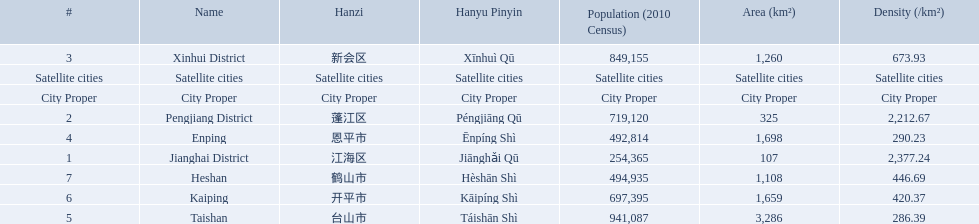Parse the full table in json format. {'header': ['#', 'Name', 'Hanzi', 'Hanyu Pinyin', 'Population (2010 Census)', 'Area (km²)', 'Density (/km²)'], 'rows': [['3', 'Xinhui District', '新会区', 'Xīnhuì Qū', '849,155', '1,260', '673.93'], ['Satellite cities', 'Satellite cities', 'Satellite cities', 'Satellite cities', 'Satellite cities', 'Satellite cities', 'Satellite cities'], ['City Proper', 'City Proper', 'City Proper', 'City Proper', 'City Proper', 'City Proper', 'City Proper'], ['2', 'Pengjiang District', '蓬江区', 'Péngjiāng Qū', '719,120', '325', '2,212.67'], ['4', 'Enping', '恩平市', 'Ēnpíng Shì', '492,814', '1,698', '290.23'], ['1', 'Jianghai District', '江海区', 'Jiānghǎi Qū', '254,365', '107', '2,377.24'], ['7', 'Heshan', '鹤山市', 'Hèshān Shì', '494,935', '1,108', '446.69'], ['6', 'Kaiping', '开平市', 'Kāipíng Shì', '697,395', '1,659', '420.37'], ['5', 'Taishan', '台山市', 'Táishān Shì', '941,087', '3,286', '286.39']]} What are all of the satellite cities? Enping, Taishan, Kaiping, Heshan. Of these, which has the highest population? Taishan. 